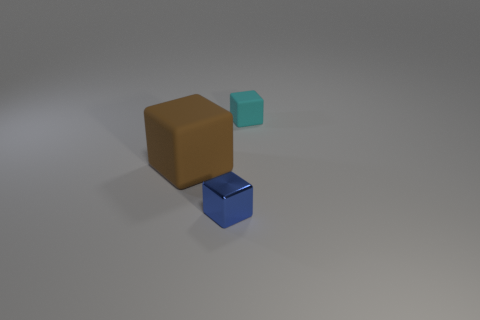How many balls are either brown matte objects or small cyan rubber objects?
Make the answer very short. 0. There is a matte object that is the same size as the metallic cube; what color is it?
Give a very brief answer. Cyan. What number of objects are on the right side of the brown matte block and behind the small metal cube?
Your answer should be very brief. 1. What is the material of the brown cube?
Your answer should be very brief. Rubber. How many things are tiny matte objects or yellow matte cylinders?
Your answer should be compact. 1. There is a cube that is behind the big brown thing; is it the same size as the matte object that is on the left side of the tiny rubber block?
Your response must be concise. No. What number of other objects are there of the same size as the cyan thing?
Ensure brevity in your answer.  1. How many objects are small cyan rubber objects that are on the right side of the brown rubber thing or cubes in front of the brown matte object?
Your answer should be very brief. 2. Is the big object made of the same material as the block on the right side of the blue object?
Your answer should be compact. Yes. How many other things are the same shape as the blue object?
Provide a succinct answer. 2. 